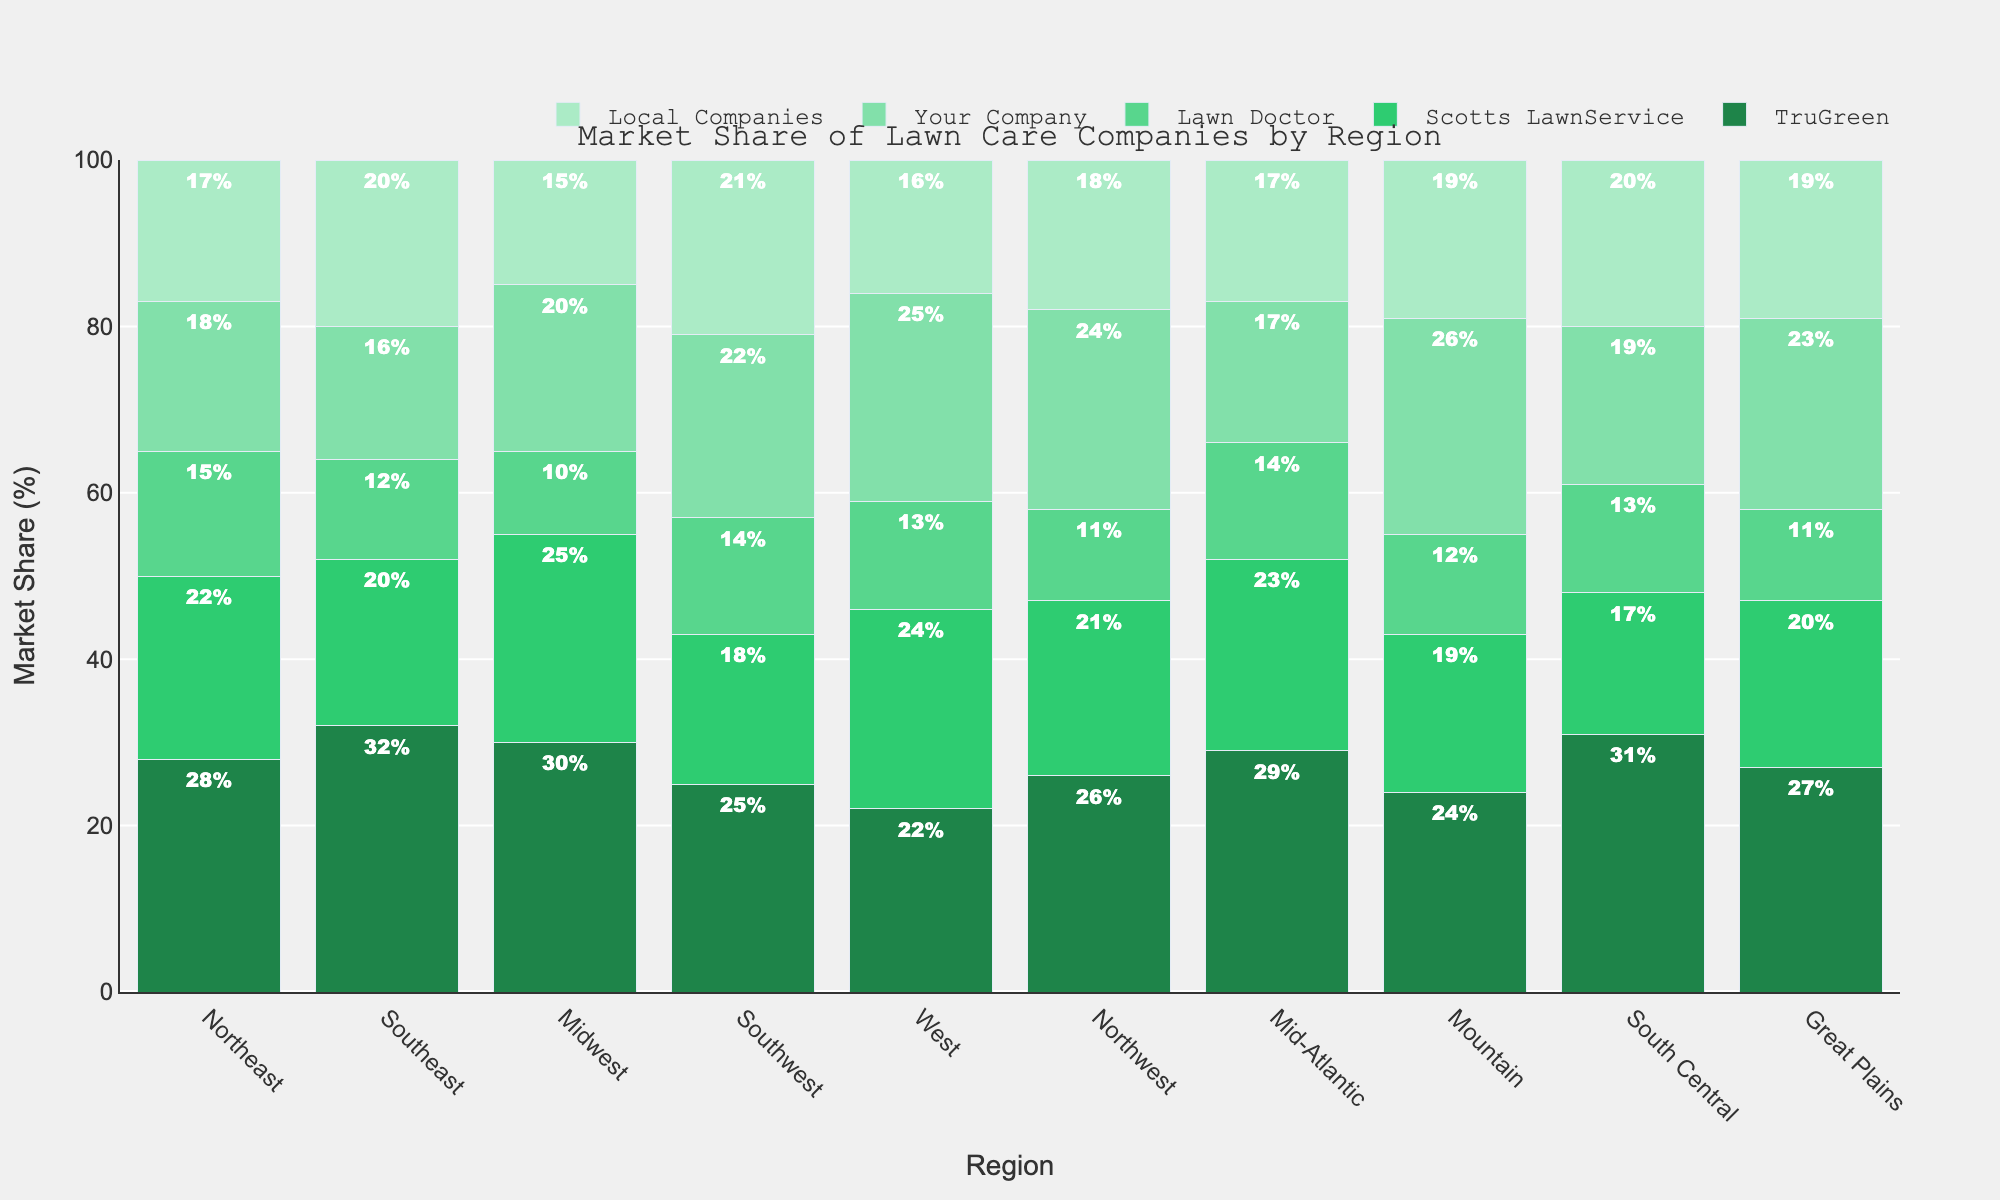What's the region where "Your Company" has the highest market share? To find the region where "Your Company" has the highest market share, look at the bar corresponding to "Your Company" for each region and identify the tallest one. The Mountain region has the tallest bar for "Your Company".
Answer: Mountain Compare the market share of TruGreen and Local Companies in the Southeast. Which one is higher and by how much? To compare the market shares, look at the heights of the bars for TruGreen and Local Companies in the Southeast region. TruGreen has a market share of 32%, and Local Companies have 20%, so TruGreen is higher by 32% - 20% = 12%.
Answer: TruGreen by 12% Which region has the most balanced market share between all companies? To find the most balanced region, observe where the bars for each company are closest in height. The West region appears to have a more balanced distribution, with all bars relatively close to each other in percentage.
Answer: West What is the total market share of Local Companies across all regions? Sum up the market share values for Local Companies in all regions: 17% (Northeast) + 20% (Southeast) + 15% (Midwest) + 21% (Southwest) + 16% (West) + 18% (Northwest) + 17% (Mid-Atlantic) + 19% (Mountain) + 20% (South Central) + 19% (Great Plains). This equals 182%.
Answer: 182% In which region is Lawn Doctor's market share the lowest? To identify the lowest market share for Lawn Doctor, look for the region where the bar for Lawn Doctor is the shortest. The Midwest and Great Plains both have the lowest value at 10% and 11%, but the Midwest is slightly lower.
Answer: Midwest By how much does "Your Company's" market share in the Southwest region exceed its market share in the Northeast region? Look at "Your Company's" bars for the Southwest and Northeast regions. In the Southwest, the market share is 22%, and in the Northeast, it is 18%. The difference is 22% - 18% = 4%.
Answer: 4% 